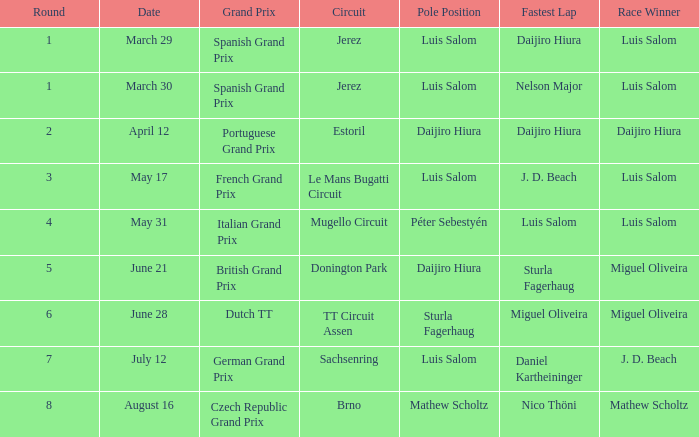On which racing circuits did luis salom have the speediest lap? Mugello Circuit. 